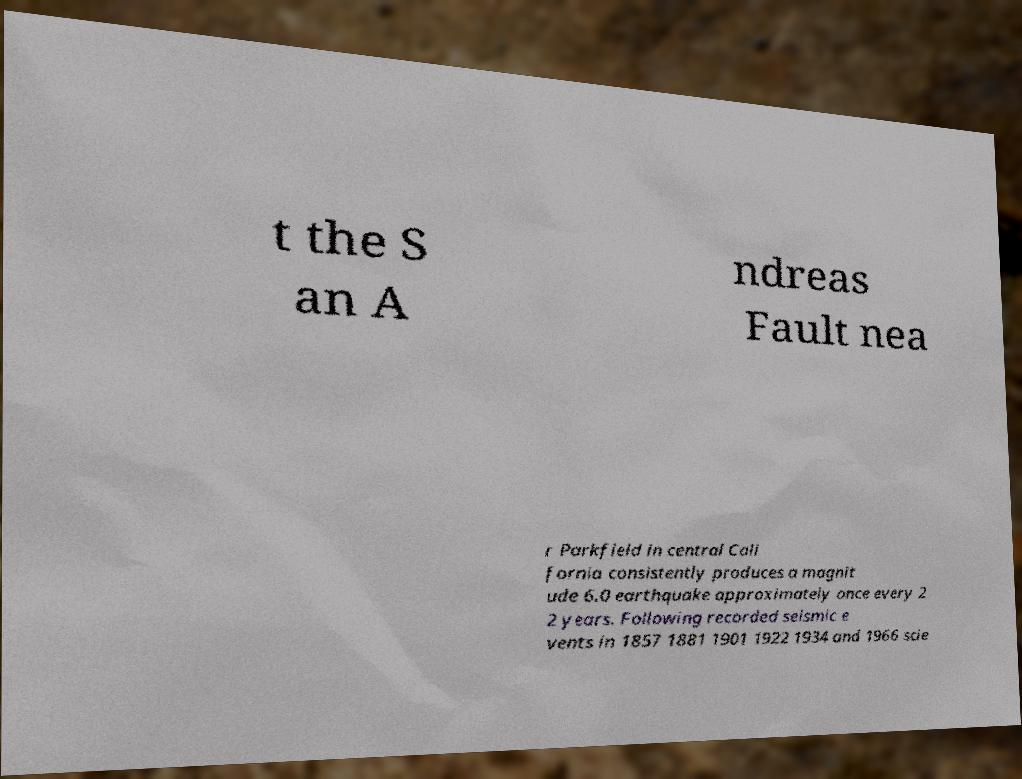Could you assist in decoding the text presented in this image and type it out clearly? t the S an A ndreas Fault nea r Parkfield in central Cali fornia consistently produces a magnit ude 6.0 earthquake approximately once every 2 2 years. Following recorded seismic e vents in 1857 1881 1901 1922 1934 and 1966 scie 